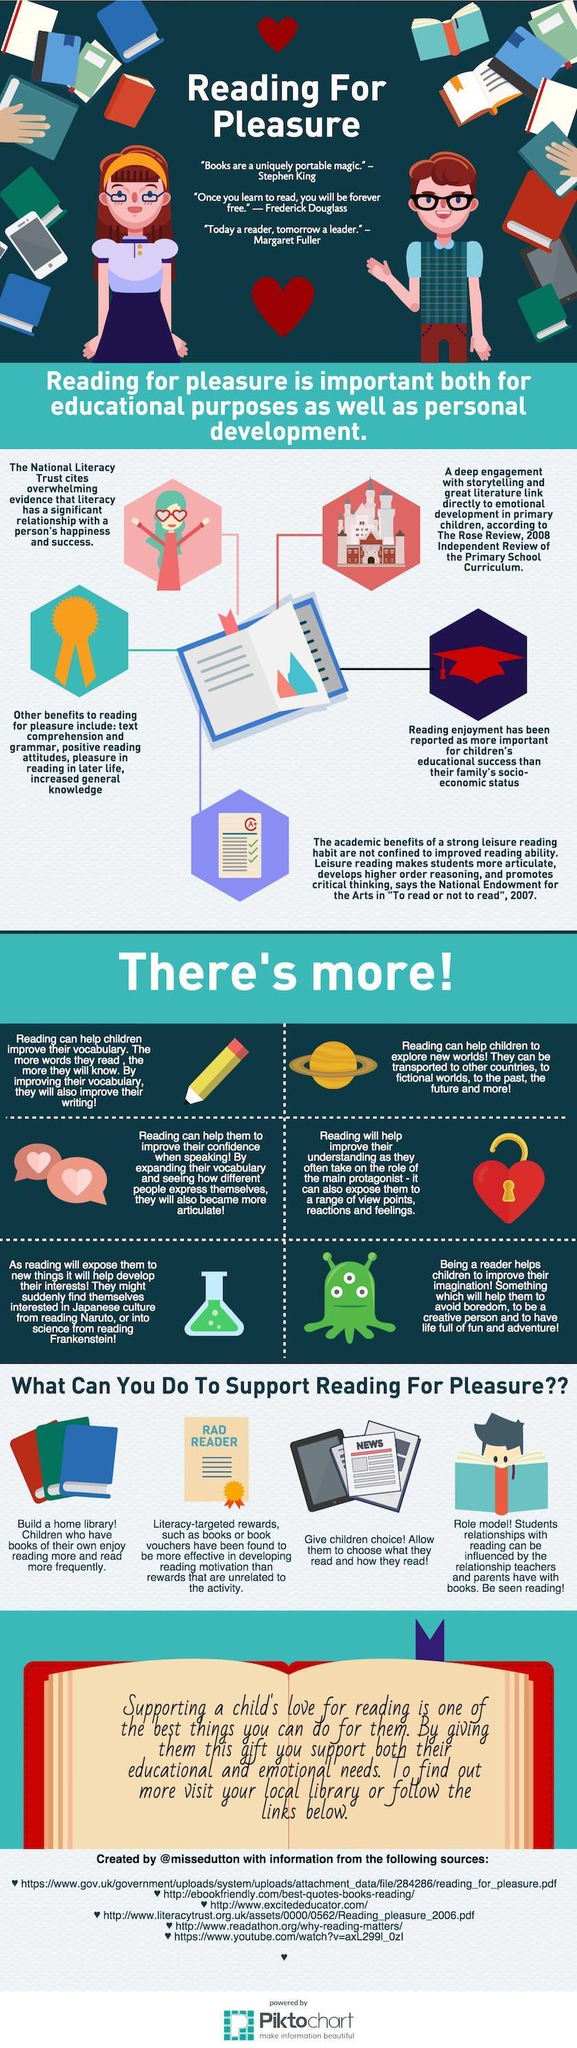What is the colour of the graduation cap show- red, blue or black?
Answer the question with a short phrase. red Which planet is shown in the infographic- Mars, Earth or Saturn? Saturn How many sources are listed at the bottom? 6 How many children are shown in the infographic? 4 What is the colour of the liquid in the measuring flask- yellow, blue or green? green 